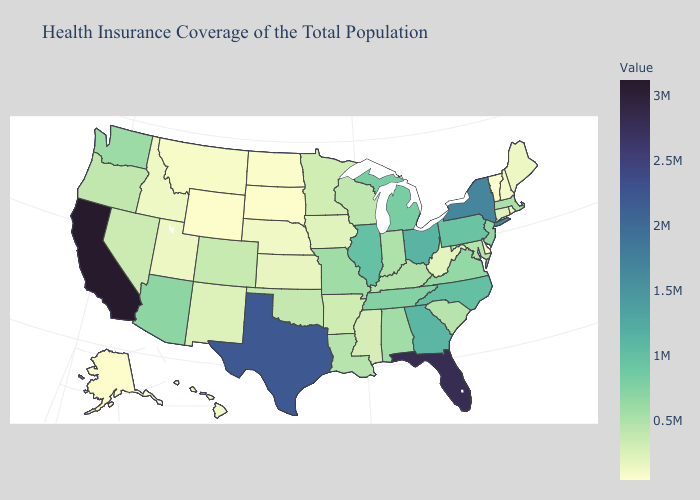Among the states that border New Mexico , does Arizona have the lowest value?
Write a very short answer. No. Among the states that border New Mexico , does Utah have the lowest value?
Give a very brief answer. Yes. 